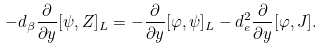Convert formula to latex. <formula><loc_0><loc_0><loc_500><loc_500>- d _ { \beta } \frac { \partial } { \partial y } [ \psi , Z ] _ { L } = - \frac { \partial } { \partial y } [ \varphi , \psi ] _ { L } - d _ { e } ^ { 2 } \frac { \partial } { \partial y } [ \varphi , J ] .</formula> 